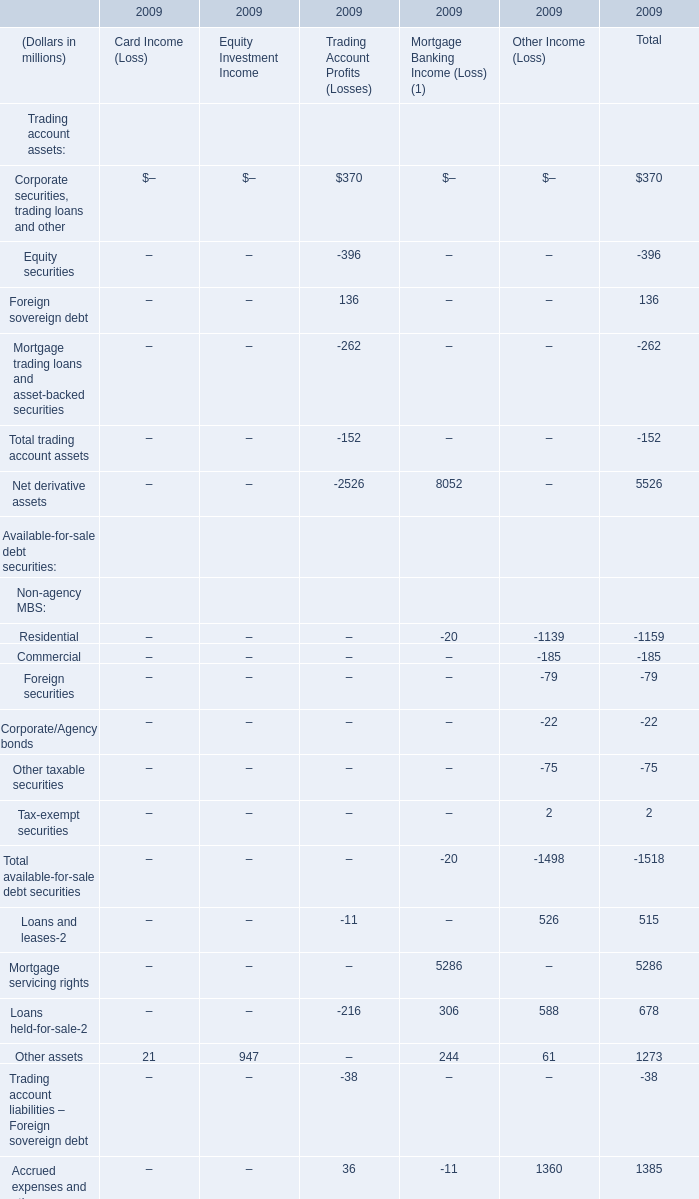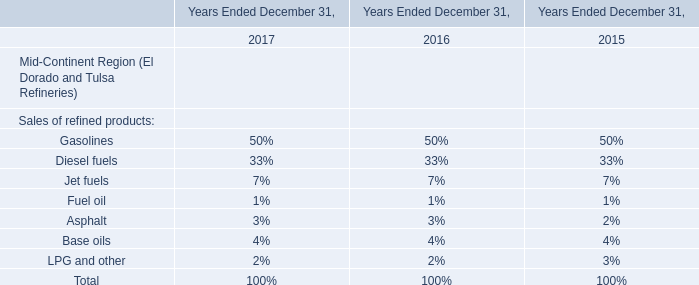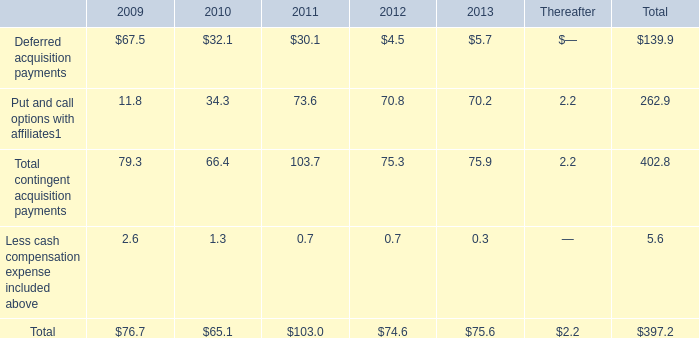If Total of Card Income (Loss) develops with the same increasing rate in 2009, what will it reach in 2010? (in million) 
Computations: (21 + ((21 * (21 - 55)) / 55))
Answer: 8.01818. 